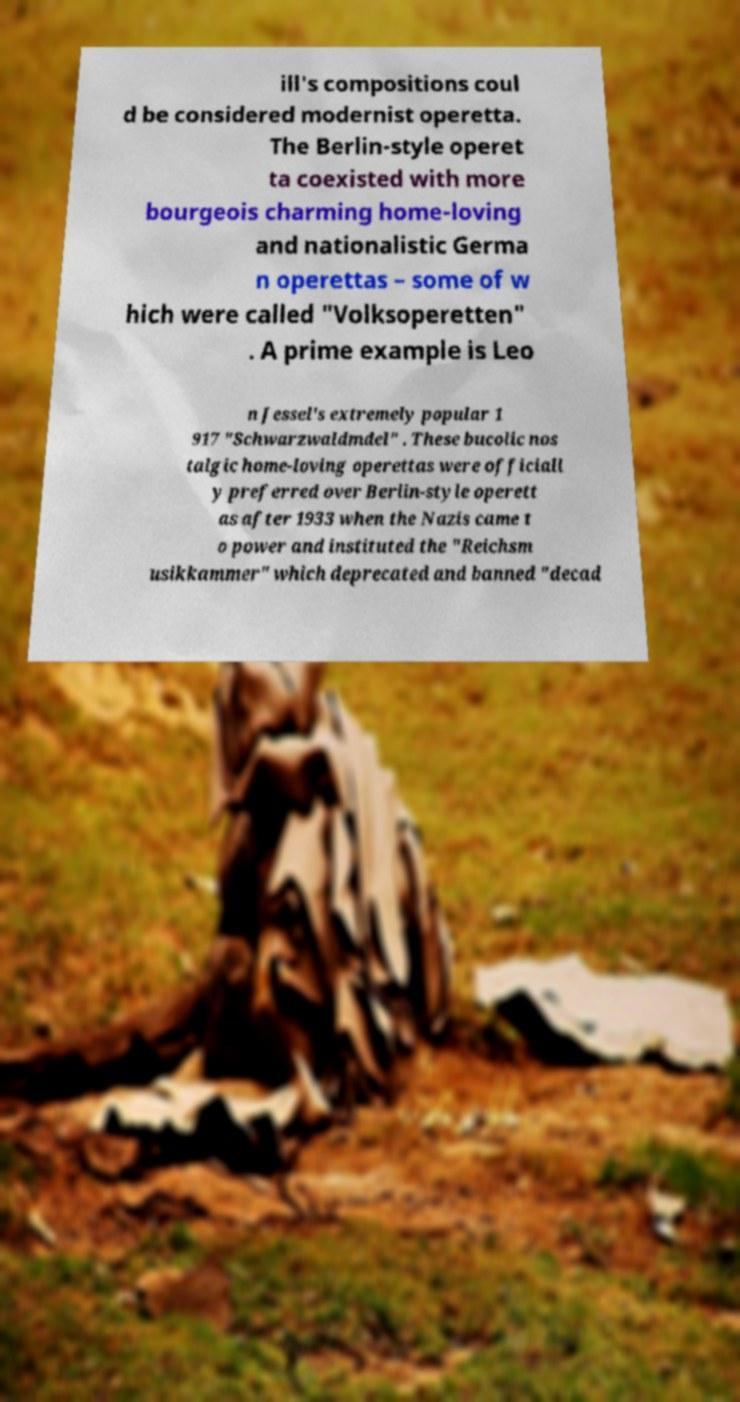Please read and relay the text visible in this image. What does it say? ill's compositions coul d be considered modernist operetta. The Berlin-style operet ta coexisted with more bourgeois charming home-loving and nationalistic Germa n operettas – some of w hich were called "Volksoperetten" . A prime example is Leo n Jessel's extremely popular 1 917 "Schwarzwaldmdel" . These bucolic nos talgic home-loving operettas were officiall y preferred over Berlin-style operett as after 1933 when the Nazis came t o power and instituted the "Reichsm usikkammer" which deprecated and banned "decad 